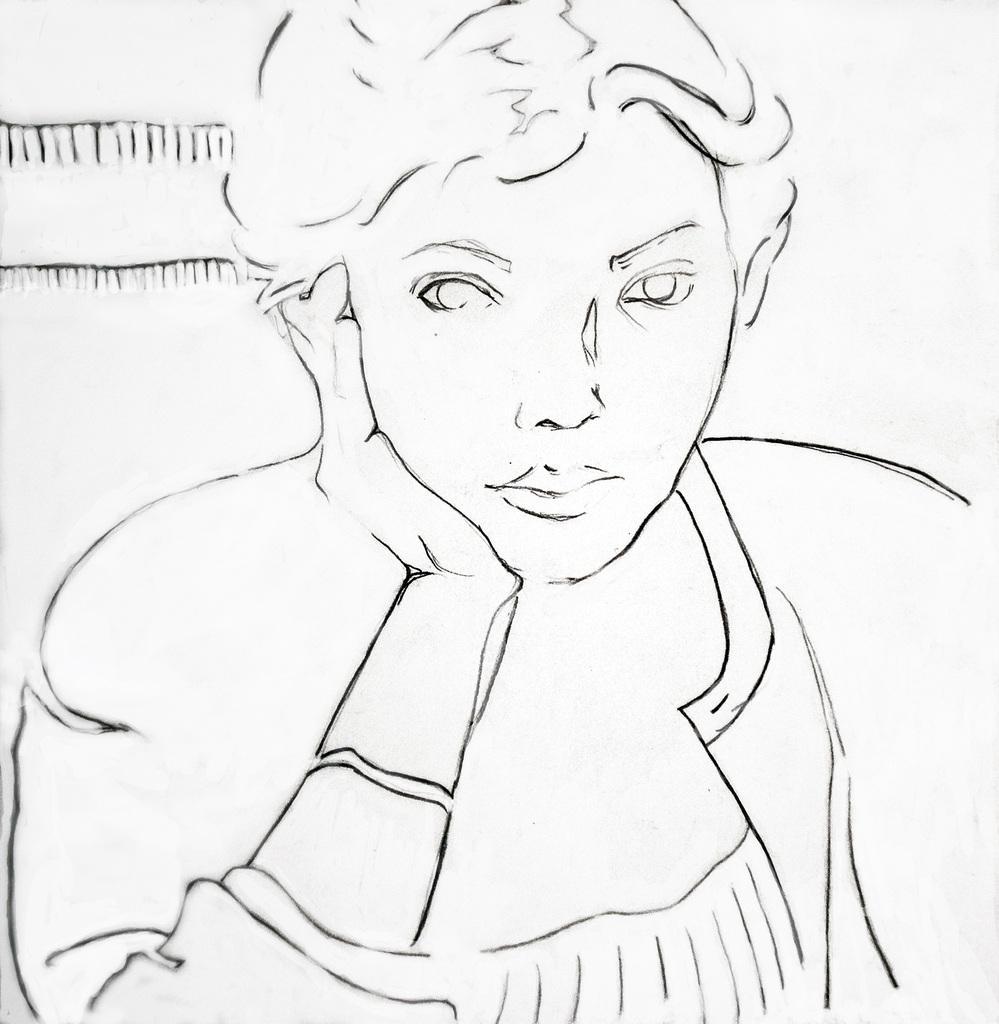How would you summarize this image in a sentence or two? This is an edited image. In this image, we can see there is a person sitting and keeping a hand under the cheek. And the background is white in color. 